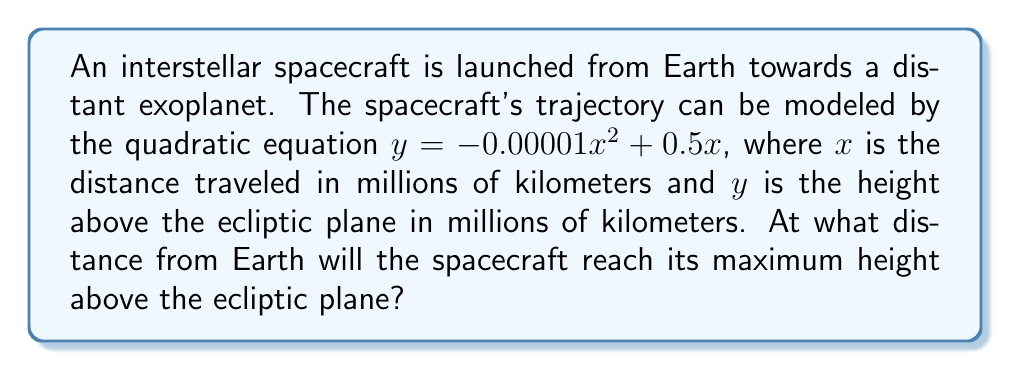Help me with this question. To find the maximum height of the spacecraft's trajectory, we need to determine the vertex of the parabola described by the quadratic equation.

Step 1: Identify the quadratic equation in standard form.
The equation $y = -0.00001x^2 + 0.5x$ is in the form $y = ax^2 + bx + c$, where:
$a = -0.00001$
$b = 0.5$
$c = 0$

Step 2: Use the formula for the x-coordinate of the vertex.
For a quadratic equation in the form $y = ax^2 + bx + c$, the x-coordinate of the vertex is given by:

$x = -\frac{b}{2a}$

Step 3: Substitute the values of $a$ and $b$ into the formula.
$$x = -\frac{0.5}{2(-0.00001)} = -\frac{0.5}{-0.00002} = 25000$$

Step 4: Interpret the result.
The spacecraft will reach its maximum height when $x = 25000$ million kilometers from Earth.
Answer: 25,000 million km 